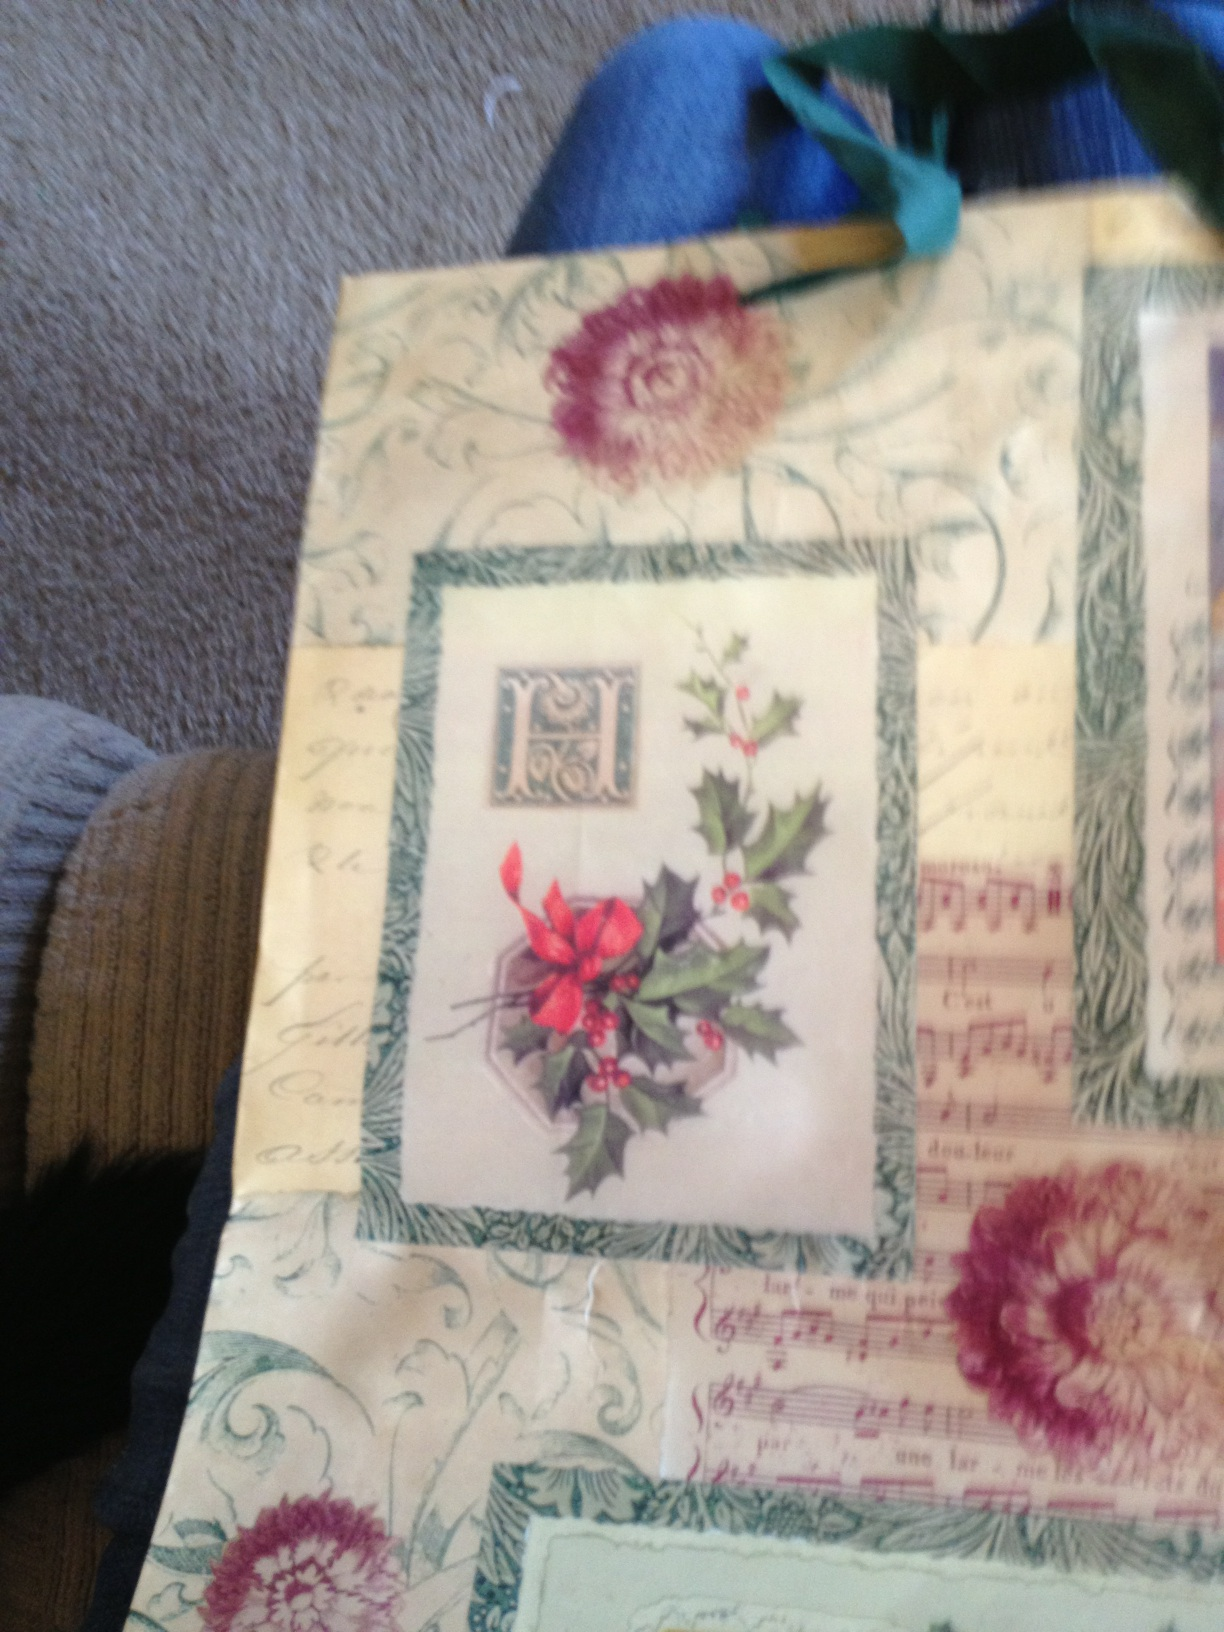Can you tell a realistic story involving this gift bag? Certainly! Once upon a winter's eve, Emma carefully wrapped a beautifully scented candle she had picked especially for her grandmother, using this charming gift bag. When her grandmother received it on Christmas morning, her eyes lit up with joy. Admiring the bag's design, she shared nostalgic stories of when she used to sing carols by the fireplace while her father played the piano, just like the old sheet music on the bag. That’s lovely. Can you tell another story? Sure! On a cold December night, Jack stumbled upon this gift bag while running late for a holiday party. Having forgotten to prepare a gift, he hastily picked out a selection of his homemade cookies and placed them inside. When he handed the bag to his friend, the vintage design and delicious cookies became the talk of the party. Jack's friend was so impressed with the thoughtfulness that he decided to frame the gift bag as a keepsake, appreciating its charm and the handmade love that came with it. 